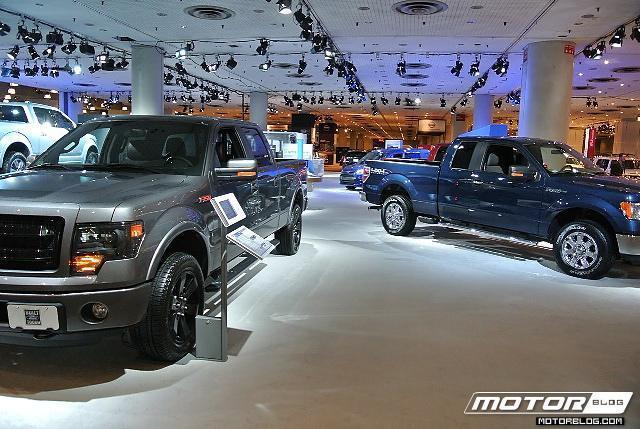How many trucks are in the picture?
Give a very brief answer. 3. 